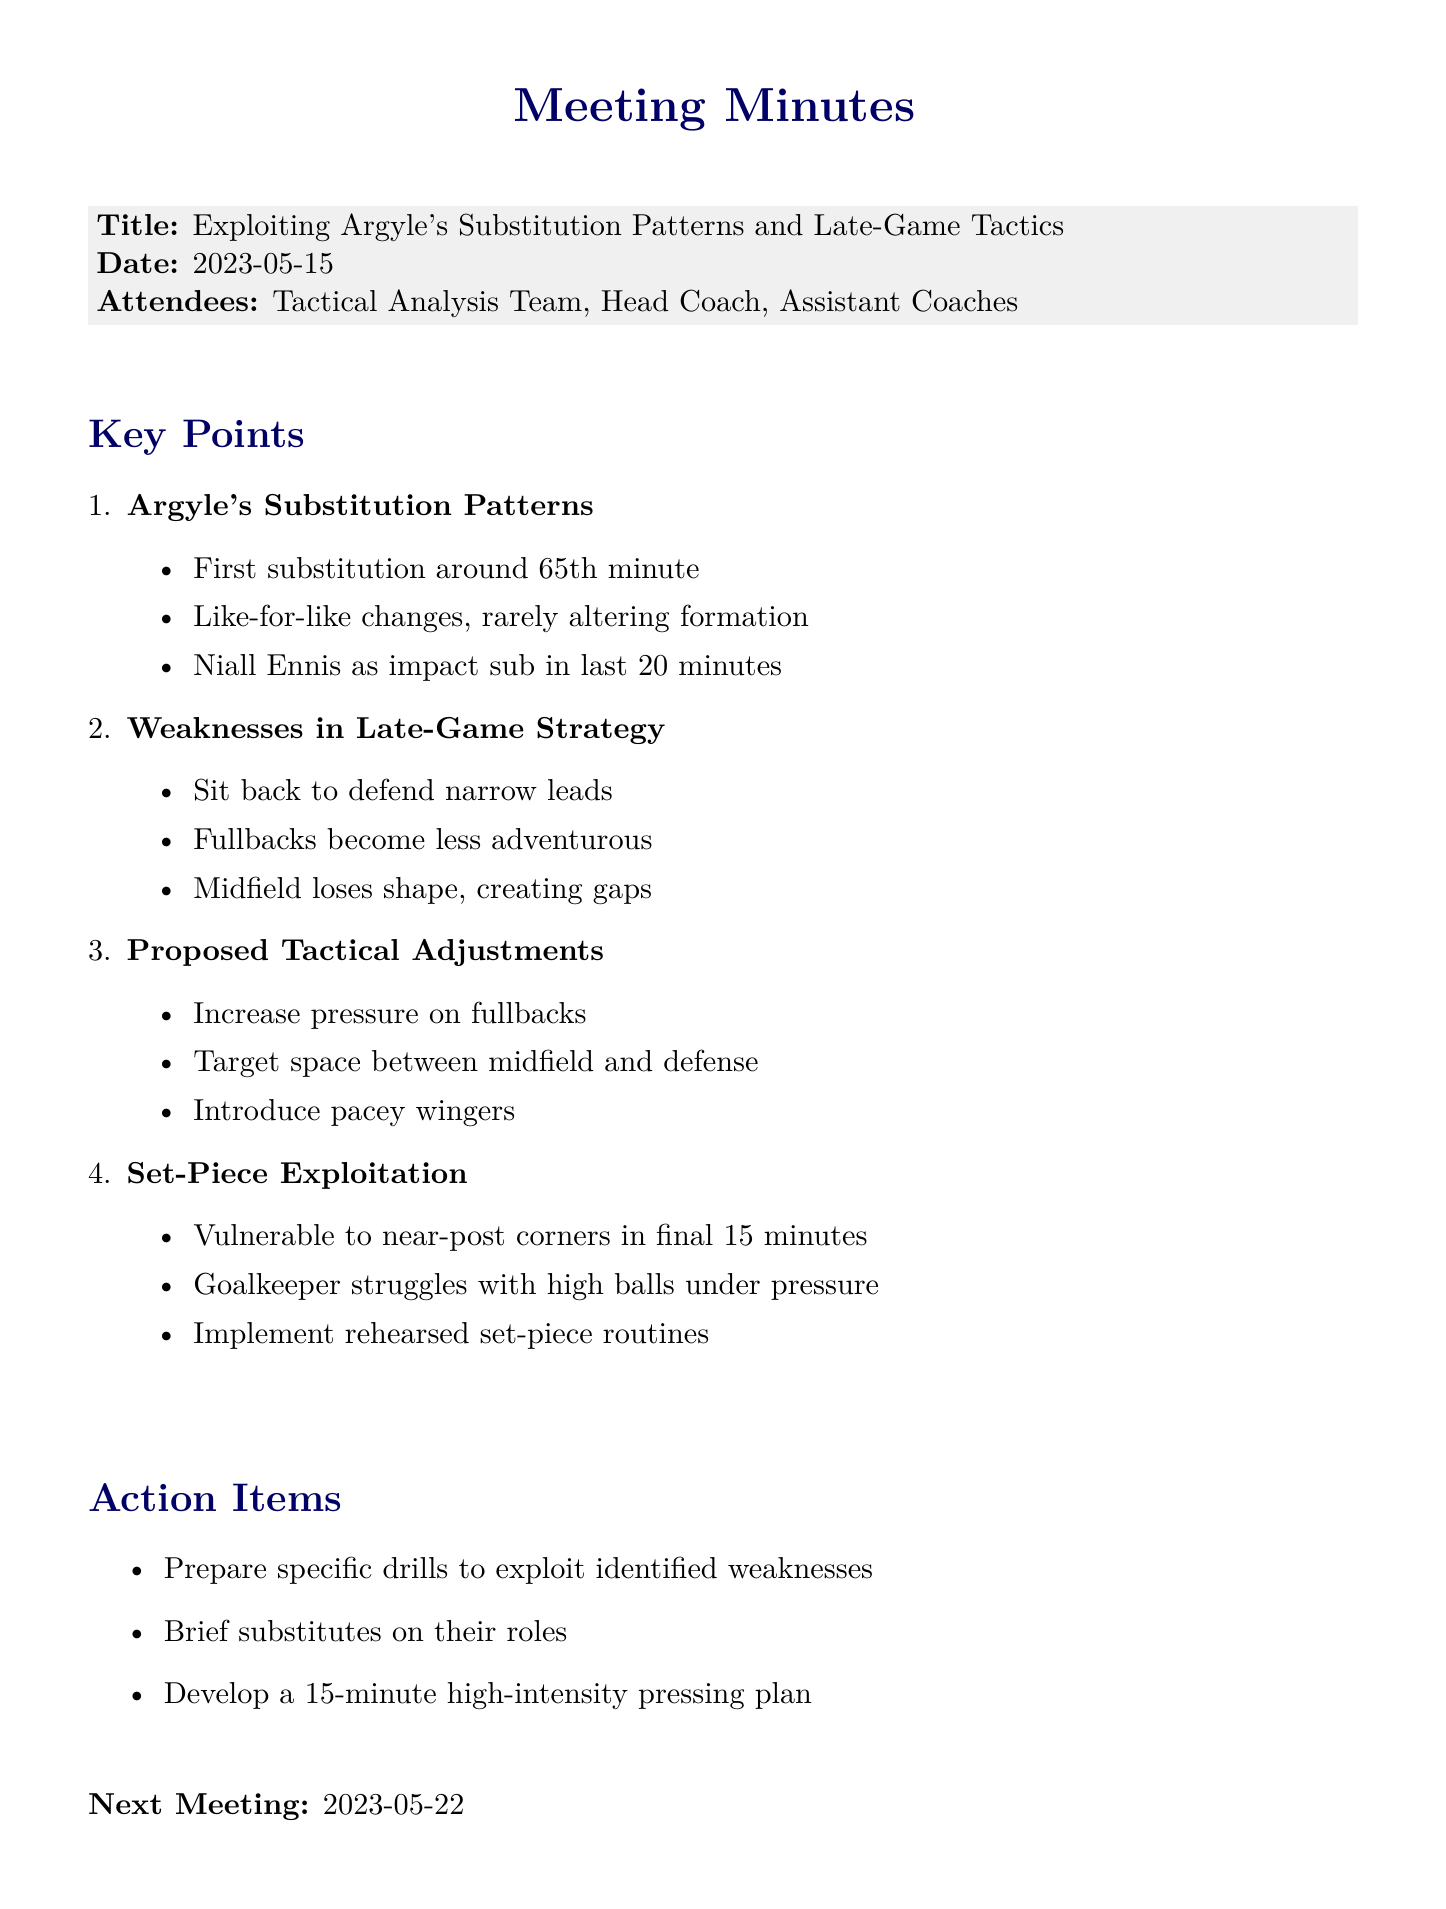What is the date of the meeting? The date of the meeting is explicitly stated in the document.
Answer: 2023-05-15 Who tends to make the first substitution? The document specifies the manager responsible for the first substitution.
Answer: Steven Schumacher What minute does the first substitution typically happen? The document mentions the typical time for the first substitution.
Answer: 65th minute Which player is often introduced as an impact sub? The document identifies a specific player used as an impact substitute.
Answer: Niall Ennis What is Argyle's tendency when protecting a lead? The document describes Argyle's strategic approach in late-game situations.
Answer: Sit back and defend narrow leads What gap is created when the midfield loses shape? The document states the specific gap that appears due to this issue.
Answer: Gaps between lines What type of adjustments are proposed to exploit Argyle's fullbacks? The document mentions the approach that will be taken regarding fullbacks.
Answer: Increase pressure When is Argyle vulnerable to near-post corners? The document specifies the time frame when Argyle is particularly vulnerable.
Answer: Final 15 minutes What is the next meeting date? The document includes information about the upcoming meeting date.
Answer: 2023-05-22 